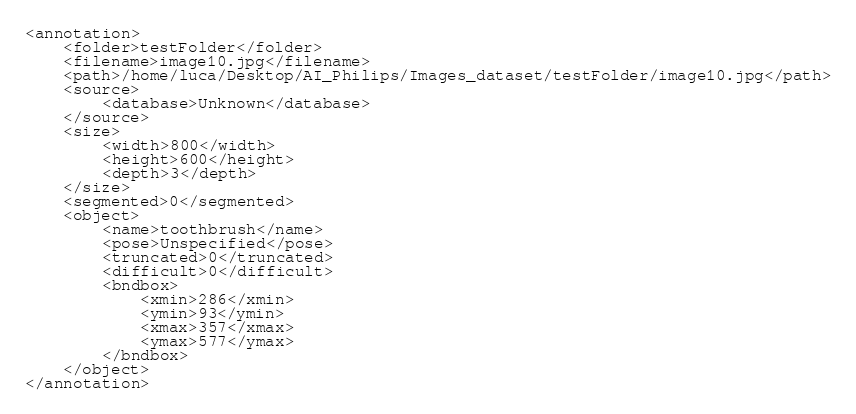<code> <loc_0><loc_0><loc_500><loc_500><_XML_><annotation>
	<folder>testFolder</folder>
	<filename>image10.jpg</filename>
	<path>/home/luca/Desktop/AI_Philips/Images_dataset/testFolder/image10.jpg</path>
	<source>
		<database>Unknown</database>
	</source>
	<size>
		<width>800</width>
		<height>600</height>
		<depth>3</depth>
	</size>
	<segmented>0</segmented>
	<object>
		<name>toothbrush</name>
		<pose>Unspecified</pose>
		<truncated>0</truncated>
		<difficult>0</difficult>
		<bndbox>
			<xmin>286</xmin>
			<ymin>93</ymin>
			<xmax>357</xmax>
			<ymax>577</ymax>
		</bndbox>
	</object>
</annotation>
</code> 